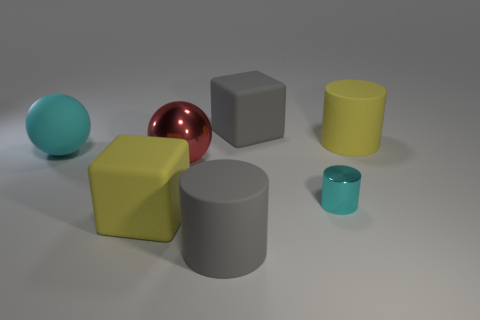Subtract all brown cylinders. Subtract all cyan spheres. How many cylinders are left? 3 Add 2 large gray blocks. How many objects exist? 9 Subtract all spheres. How many objects are left? 5 Subtract 1 yellow cubes. How many objects are left? 6 Subtract all gray objects. Subtract all small cyan metallic spheres. How many objects are left? 5 Add 5 metallic cylinders. How many metallic cylinders are left? 6 Add 2 metal objects. How many metal objects exist? 4 